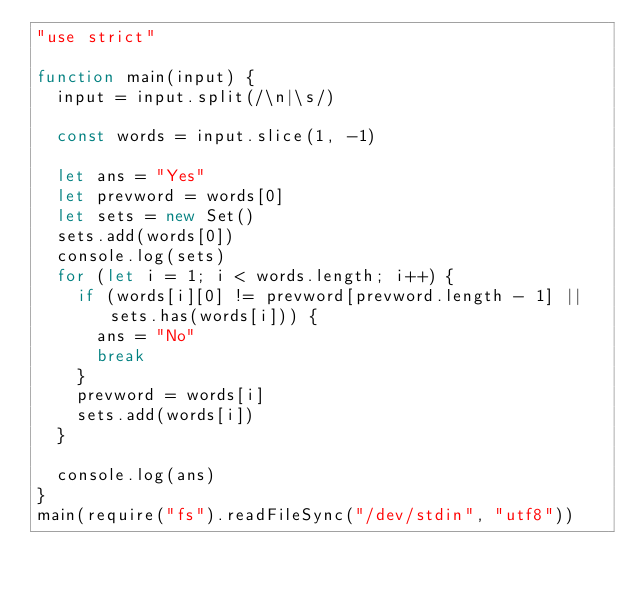Convert code to text. <code><loc_0><loc_0><loc_500><loc_500><_JavaScript_>"use strict"

function main(input) {
  input = input.split(/\n|\s/)

  const words = input.slice(1, -1)

  let ans = "Yes"
  let prevword = words[0]
  let sets = new Set()
  sets.add(words[0])
  console.log(sets)
  for (let i = 1; i < words.length; i++) {
    if (words[i][0] != prevword[prevword.length - 1] || sets.has(words[i])) {
      ans = "No"
      break
    }
    prevword = words[i]
    sets.add(words[i])
  }

  console.log(ans)
}
main(require("fs").readFileSync("/dev/stdin", "utf8"))
</code> 